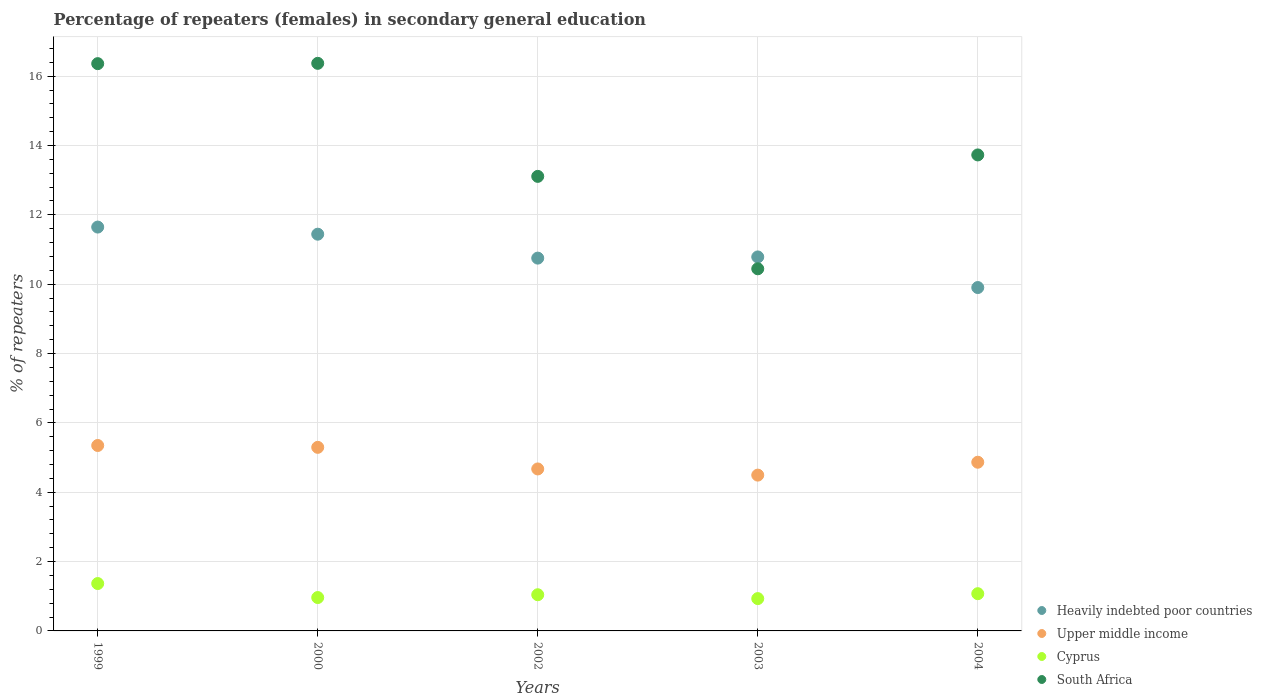What is the percentage of female repeaters in Heavily indebted poor countries in 1999?
Your answer should be compact. 11.65. Across all years, what is the maximum percentage of female repeaters in South Africa?
Your response must be concise. 16.37. Across all years, what is the minimum percentage of female repeaters in South Africa?
Your answer should be compact. 10.44. In which year was the percentage of female repeaters in South Africa maximum?
Keep it short and to the point. 2000. What is the total percentage of female repeaters in Cyprus in the graph?
Give a very brief answer. 5.38. What is the difference between the percentage of female repeaters in Heavily indebted poor countries in 1999 and that in 2004?
Offer a very short reply. 1.74. What is the difference between the percentage of female repeaters in Upper middle income in 2004 and the percentage of female repeaters in Cyprus in 2002?
Provide a succinct answer. 3.82. What is the average percentage of female repeaters in Heavily indebted poor countries per year?
Your answer should be very brief. 10.91. In the year 2004, what is the difference between the percentage of female repeaters in Cyprus and percentage of female repeaters in Heavily indebted poor countries?
Provide a succinct answer. -8.83. In how many years, is the percentage of female repeaters in Heavily indebted poor countries greater than 12.4 %?
Your answer should be compact. 0. What is the ratio of the percentage of female repeaters in South Africa in 1999 to that in 2004?
Provide a short and direct response. 1.19. Is the difference between the percentage of female repeaters in Cyprus in 1999 and 2002 greater than the difference between the percentage of female repeaters in Heavily indebted poor countries in 1999 and 2002?
Offer a very short reply. No. What is the difference between the highest and the second highest percentage of female repeaters in Cyprus?
Ensure brevity in your answer.  0.29. What is the difference between the highest and the lowest percentage of female repeaters in Cyprus?
Provide a short and direct response. 0.43. Is it the case that in every year, the sum of the percentage of female repeaters in Upper middle income and percentage of female repeaters in Heavily indebted poor countries  is greater than the sum of percentage of female repeaters in Cyprus and percentage of female repeaters in South Africa?
Your answer should be very brief. No. Is the percentage of female repeaters in Cyprus strictly greater than the percentage of female repeaters in Heavily indebted poor countries over the years?
Offer a very short reply. No. How many dotlines are there?
Keep it short and to the point. 4. Does the graph contain grids?
Offer a terse response. Yes. How many legend labels are there?
Your response must be concise. 4. What is the title of the graph?
Your response must be concise. Percentage of repeaters (females) in secondary general education. What is the label or title of the Y-axis?
Keep it short and to the point. % of repeaters. What is the % of repeaters in Heavily indebted poor countries in 1999?
Your answer should be compact. 11.65. What is the % of repeaters in Upper middle income in 1999?
Provide a succinct answer. 5.35. What is the % of repeaters in Cyprus in 1999?
Keep it short and to the point. 1.37. What is the % of repeaters of South Africa in 1999?
Offer a terse response. 16.36. What is the % of repeaters of Heavily indebted poor countries in 2000?
Keep it short and to the point. 11.44. What is the % of repeaters in Upper middle income in 2000?
Your answer should be compact. 5.29. What is the % of repeaters in Cyprus in 2000?
Provide a succinct answer. 0.96. What is the % of repeaters in South Africa in 2000?
Make the answer very short. 16.37. What is the % of repeaters in Heavily indebted poor countries in 2002?
Offer a terse response. 10.75. What is the % of repeaters in Upper middle income in 2002?
Your response must be concise. 4.67. What is the % of repeaters of Cyprus in 2002?
Offer a terse response. 1.04. What is the % of repeaters of South Africa in 2002?
Keep it short and to the point. 13.11. What is the % of repeaters in Heavily indebted poor countries in 2003?
Give a very brief answer. 10.79. What is the % of repeaters in Upper middle income in 2003?
Offer a very short reply. 4.49. What is the % of repeaters in Cyprus in 2003?
Your answer should be compact. 0.93. What is the % of repeaters of South Africa in 2003?
Offer a very short reply. 10.44. What is the % of repeaters of Heavily indebted poor countries in 2004?
Offer a terse response. 9.9. What is the % of repeaters of Upper middle income in 2004?
Make the answer very short. 4.86. What is the % of repeaters of Cyprus in 2004?
Offer a very short reply. 1.07. What is the % of repeaters of South Africa in 2004?
Provide a short and direct response. 13.73. Across all years, what is the maximum % of repeaters in Heavily indebted poor countries?
Your answer should be very brief. 11.65. Across all years, what is the maximum % of repeaters in Upper middle income?
Provide a short and direct response. 5.35. Across all years, what is the maximum % of repeaters in Cyprus?
Ensure brevity in your answer.  1.37. Across all years, what is the maximum % of repeaters in South Africa?
Offer a terse response. 16.37. Across all years, what is the minimum % of repeaters in Heavily indebted poor countries?
Make the answer very short. 9.9. Across all years, what is the minimum % of repeaters in Upper middle income?
Provide a short and direct response. 4.49. Across all years, what is the minimum % of repeaters in Cyprus?
Provide a short and direct response. 0.93. Across all years, what is the minimum % of repeaters of South Africa?
Your response must be concise. 10.44. What is the total % of repeaters in Heavily indebted poor countries in the graph?
Your answer should be very brief. 54.53. What is the total % of repeaters in Upper middle income in the graph?
Offer a terse response. 24.67. What is the total % of repeaters in Cyprus in the graph?
Provide a succinct answer. 5.38. What is the total % of repeaters in South Africa in the graph?
Give a very brief answer. 70.01. What is the difference between the % of repeaters in Heavily indebted poor countries in 1999 and that in 2000?
Ensure brevity in your answer.  0.21. What is the difference between the % of repeaters in Upper middle income in 1999 and that in 2000?
Give a very brief answer. 0.05. What is the difference between the % of repeaters of Cyprus in 1999 and that in 2000?
Your answer should be compact. 0.4. What is the difference between the % of repeaters of South Africa in 1999 and that in 2000?
Your response must be concise. -0.01. What is the difference between the % of repeaters of Heavily indebted poor countries in 1999 and that in 2002?
Make the answer very short. 0.9. What is the difference between the % of repeaters of Upper middle income in 1999 and that in 2002?
Offer a very short reply. 0.68. What is the difference between the % of repeaters in Cyprus in 1999 and that in 2002?
Keep it short and to the point. 0.32. What is the difference between the % of repeaters in South Africa in 1999 and that in 2002?
Offer a very short reply. 3.25. What is the difference between the % of repeaters of Heavily indebted poor countries in 1999 and that in 2003?
Your response must be concise. 0.86. What is the difference between the % of repeaters of Upper middle income in 1999 and that in 2003?
Your answer should be compact. 0.85. What is the difference between the % of repeaters of Cyprus in 1999 and that in 2003?
Keep it short and to the point. 0.43. What is the difference between the % of repeaters of South Africa in 1999 and that in 2003?
Make the answer very short. 5.92. What is the difference between the % of repeaters in Heavily indebted poor countries in 1999 and that in 2004?
Your answer should be very brief. 1.74. What is the difference between the % of repeaters in Upper middle income in 1999 and that in 2004?
Provide a succinct answer. 0.48. What is the difference between the % of repeaters in Cyprus in 1999 and that in 2004?
Keep it short and to the point. 0.29. What is the difference between the % of repeaters of South Africa in 1999 and that in 2004?
Your answer should be very brief. 2.63. What is the difference between the % of repeaters in Heavily indebted poor countries in 2000 and that in 2002?
Offer a very short reply. 0.69. What is the difference between the % of repeaters in Upper middle income in 2000 and that in 2002?
Keep it short and to the point. 0.62. What is the difference between the % of repeaters in Cyprus in 2000 and that in 2002?
Ensure brevity in your answer.  -0.08. What is the difference between the % of repeaters in South Africa in 2000 and that in 2002?
Your answer should be very brief. 3.26. What is the difference between the % of repeaters in Heavily indebted poor countries in 2000 and that in 2003?
Provide a succinct answer. 0.66. What is the difference between the % of repeaters in Upper middle income in 2000 and that in 2003?
Provide a succinct answer. 0.8. What is the difference between the % of repeaters in Cyprus in 2000 and that in 2003?
Your answer should be very brief. 0.03. What is the difference between the % of repeaters in South Africa in 2000 and that in 2003?
Offer a very short reply. 5.93. What is the difference between the % of repeaters of Heavily indebted poor countries in 2000 and that in 2004?
Your answer should be compact. 1.54. What is the difference between the % of repeaters of Upper middle income in 2000 and that in 2004?
Your answer should be compact. 0.43. What is the difference between the % of repeaters of Cyprus in 2000 and that in 2004?
Your answer should be compact. -0.11. What is the difference between the % of repeaters of South Africa in 2000 and that in 2004?
Offer a very short reply. 2.64. What is the difference between the % of repeaters of Heavily indebted poor countries in 2002 and that in 2003?
Keep it short and to the point. -0.03. What is the difference between the % of repeaters of Upper middle income in 2002 and that in 2003?
Keep it short and to the point. 0.18. What is the difference between the % of repeaters in Cyprus in 2002 and that in 2003?
Your response must be concise. 0.11. What is the difference between the % of repeaters of South Africa in 2002 and that in 2003?
Offer a terse response. 2.67. What is the difference between the % of repeaters of Heavily indebted poor countries in 2002 and that in 2004?
Make the answer very short. 0.85. What is the difference between the % of repeaters of Upper middle income in 2002 and that in 2004?
Provide a short and direct response. -0.19. What is the difference between the % of repeaters in Cyprus in 2002 and that in 2004?
Your response must be concise. -0.03. What is the difference between the % of repeaters in South Africa in 2002 and that in 2004?
Make the answer very short. -0.62. What is the difference between the % of repeaters of Heavily indebted poor countries in 2003 and that in 2004?
Provide a short and direct response. 0.88. What is the difference between the % of repeaters in Upper middle income in 2003 and that in 2004?
Your answer should be compact. -0.37. What is the difference between the % of repeaters of Cyprus in 2003 and that in 2004?
Give a very brief answer. -0.14. What is the difference between the % of repeaters of South Africa in 2003 and that in 2004?
Ensure brevity in your answer.  -3.28. What is the difference between the % of repeaters of Heavily indebted poor countries in 1999 and the % of repeaters of Upper middle income in 2000?
Keep it short and to the point. 6.35. What is the difference between the % of repeaters in Heavily indebted poor countries in 1999 and the % of repeaters in Cyprus in 2000?
Offer a terse response. 10.68. What is the difference between the % of repeaters of Heavily indebted poor countries in 1999 and the % of repeaters of South Africa in 2000?
Provide a succinct answer. -4.72. What is the difference between the % of repeaters in Upper middle income in 1999 and the % of repeaters in Cyprus in 2000?
Ensure brevity in your answer.  4.39. What is the difference between the % of repeaters in Upper middle income in 1999 and the % of repeaters in South Africa in 2000?
Offer a very short reply. -11.02. What is the difference between the % of repeaters of Cyprus in 1999 and the % of repeaters of South Africa in 2000?
Provide a succinct answer. -15. What is the difference between the % of repeaters of Heavily indebted poor countries in 1999 and the % of repeaters of Upper middle income in 2002?
Your answer should be compact. 6.98. What is the difference between the % of repeaters of Heavily indebted poor countries in 1999 and the % of repeaters of Cyprus in 2002?
Provide a short and direct response. 10.6. What is the difference between the % of repeaters in Heavily indebted poor countries in 1999 and the % of repeaters in South Africa in 2002?
Offer a terse response. -1.46. What is the difference between the % of repeaters in Upper middle income in 1999 and the % of repeaters in Cyprus in 2002?
Offer a very short reply. 4.3. What is the difference between the % of repeaters of Upper middle income in 1999 and the % of repeaters of South Africa in 2002?
Provide a short and direct response. -7.76. What is the difference between the % of repeaters of Cyprus in 1999 and the % of repeaters of South Africa in 2002?
Your answer should be very brief. -11.74. What is the difference between the % of repeaters in Heavily indebted poor countries in 1999 and the % of repeaters in Upper middle income in 2003?
Ensure brevity in your answer.  7.15. What is the difference between the % of repeaters of Heavily indebted poor countries in 1999 and the % of repeaters of Cyprus in 2003?
Your answer should be compact. 10.71. What is the difference between the % of repeaters of Heavily indebted poor countries in 1999 and the % of repeaters of South Africa in 2003?
Offer a terse response. 1.2. What is the difference between the % of repeaters in Upper middle income in 1999 and the % of repeaters in Cyprus in 2003?
Offer a terse response. 4.42. What is the difference between the % of repeaters in Upper middle income in 1999 and the % of repeaters in South Africa in 2003?
Provide a succinct answer. -5.1. What is the difference between the % of repeaters of Cyprus in 1999 and the % of repeaters of South Africa in 2003?
Provide a short and direct response. -9.08. What is the difference between the % of repeaters in Heavily indebted poor countries in 1999 and the % of repeaters in Upper middle income in 2004?
Offer a very short reply. 6.78. What is the difference between the % of repeaters in Heavily indebted poor countries in 1999 and the % of repeaters in Cyprus in 2004?
Ensure brevity in your answer.  10.57. What is the difference between the % of repeaters of Heavily indebted poor countries in 1999 and the % of repeaters of South Africa in 2004?
Your answer should be very brief. -2.08. What is the difference between the % of repeaters in Upper middle income in 1999 and the % of repeaters in Cyprus in 2004?
Make the answer very short. 4.27. What is the difference between the % of repeaters in Upper middle income in 1999 and the % of repeaters in South Africa in 2004?
Offer a terse response. -8.38. What is the difference between the % of repeaters in Cyprus in 1999 and the % of repeaters in South Africa in 2004?
Your response must be concise. -12.36. What is the difference between the % of repeaters in Heavily indebted poor countries in 2000 and the % of repeaters in Upper middle income in 2002?
Provide a short and direct response. 6.77. What is the difference between the % of repeaters in Heavily indebted poor countries in 2000 and the % of repeaters in Cyprus in 2002?
Your answer should be very brief. 10.4. What is the difference between the % of repeaters of Heavily indebted poor countries in 2000 and the % of repeaters of South Africa in 2002?
Offer a terse response. -1.67. What is the difference between the % of repeaters of Upper middle income in 2000 and the % of repeaters of Cyprus in 2002?
Make the answer very short. 4.25. What is the difference between the % of repeaters of Upper middle income in 2000 and the % of repeaters of South Africa in 2002?
Your response must be concise. -7.81. What is the difference between the % of repeaters of Cyprus in 2000 and the % of repeaters of South Africa in 2002?
Provide a succinct answer. -12.15. What is the difference between the % of repeaters of Heavily indebted poor countries in 2000 and the % of repeaters of Upper middle income in 2003?
Keep it short and to the point. 6.95. What is the difference between the % of repeaters in Heavily indebted poor countries in 2000 and the % of repeaters in Cyprus in 2003?
Offer a terse response. 10.51. What is the difference between the % of repeaters of Upper middle income in 2000 and the % of repeaters of Cyprus in 2003?
Offer a very short reply. 4.36. What is the difference between the % of repeaters in Upper middle income in 2000 and the % of repeaters in South Africa in 2003?
Give a very brief answer. -5.15. What is the difference between the % of repeaters in Cyprus in 2000 and the % of repeaters in South Africa in 2003?
Keep it short and to the point. -9.48. What is the difference between the % of repeaters of Heavily indebted poor countries in 2000 and the % of repeaters of Upper middle income in 2004?
Your answer should be compact. 6.58. What is the difference between the % of repeaters of Heavily indebted poor countries in 2000 and the % of repeaters of Cyprus in 2004?
Provide a succinct answer. 10.37. What is the difference between the % of repeaters of Heavily indebted poor countries in 2000 and the % of repeaters of South Africa in 2004?
Ensure brevity in your answer.  -2.29. What is the difference between the % of repeaters of Upper middle income in 2000 and the % of repeaters of Cyprus in 2004?
Your answer should be very brief. 4.22. What is the difference between the % of repeaters of Upper middle income in 2000 and the % of repeaters of South Africa in 2004?
Your response must be concise. -8.43. What is the difference between the % of repeaters in Cyprus in 2000 and the % of repeaters in South Africa in 2004?
Make the answer very short. -12.76. What is the difference between the % of repeaters of Heavily indebted poor countries in 2002 and the % of repeaters of Upper middle income in 2003?
Offer a terse response. 6.26. What is the difference between the % of repeaters in Heavily indebted poor countries in 2002 and the % of repeaters in Cyprus in 2003?
Make the answer very short. 9.82. What is the difference between the % of repeaters of Heavily indebted poor countries in 2002 and the % of repeaters of South Africa in 2003?
Your answer should be very brief. 0.31. What is the difference between the % of repeaters in Upper middle income in 2002 and the % of repeaters in Cyprus in 2003?
Offer a terse response. 3.74. What is the difference between the % of repeaters of Upper middle income in 2002 and the % of repeaters of South Africa in 2003?
Offer a very short reply. -5.77. What is the difference between the % of repeaters in Cyprus in 2002 and the % of repeaters in South Africa in 2003?
Provide a succinct answer. -9.4. What is the difference between the % of repeaters in Heavily indebted poor countries in 2002 and the % of repeaters in Upper middle income in 2004?
Your answer should be very brief. 5.89. What is the difference between the % of repeaters in Heavily indebted poor countries in 2002 and the % of repeaters in Cyprus in 2004?
Your answer should be very brief. 9.68. What is the difference between the % of repeaters in Heavily indebted poor countries in 2002 and the % of repeaters in South Africa in 2004?
Offer a very short reply. -2.98. What is the difference between the % of repeaters in Upper middle income in 2002 and the % of repeaters in Cyprus in 2004?
Your answer should be very brief. 3.6. What is the difference between the % of repeaters in Upper middle income in 2002 and the % of repeaters in South Africa in 2004?
Offer a very short reply. -9.06. What is the difference between the % of repeaters in Cyprus in 2002 and the % of repeaters in South Africa in 2004?
Your answer should be very brief. -12.68. What is the difference between the % of repeaters of Heavily indebted poor countries in 2003 and the % of repeaters of Upper middle income in 2004?
Your answer should be compact. 5.92. What is the difference between the % of repeaters in Heavily indebted poor countries in 2003 and the % of repeaters in Cyprus in 2004?
Your response must be concise. 9.71. What is the difference between the % of repeaters in Heavily indebted poor countries in 2003 and the % of repeaters in South Africa in 2004?
Provide a succinct answer. -2.94. What is the difference between the % of repeaters of Upper middle income in 2003 and the % of repeaters of Cyprus in 2004?
Make the answer very short. 3.42. What is the difference between the % of repeaters in Upper middle income in 2003 and the % of repeaters in South Africa in 2004?
Your answer should be compact. -9.23. What is the difference between the % of repeaters of Cyprus in 2003 and the % of repeaters of South Africa in 2004?
Provide a succinct answer. -12.8. What is the average % of repeaters in Heavily indebted poor countries per year?
Your answer should be compact. 10.91. What is the average % of repeaters in Upper middle income per year?
Provide a succinct answer. 4.93. What is the average % of repeaters in Cyprus per year?
Your response must be concise. 1.08. What is the average % of repeaters of South Africa per year?
Your answer should be compact. 14. In the year 1999, what is the difference between the % of repeaters in Heavily indebted poor countries and % of repeaters in Upper middle income?
Provide a short and direct response. 6.3. In the year 1999, what is the difference between the % of repeaters of Heavily indebted poor countries and % of repeaters of Cyprus?
Keep it short and to the point. 10.28. In the year 1999, what is the difference between the % of repeaters of Heavily indebted poor countries and % of repeaters of South Africa?
Offer a terse response. -4.71. In the year 1999, what is the difference between the % of repeaters of Upper middle income and % of repeaters of Cyprus?
Give a very brief answer. 3.98. In the year 1999, what is the difference between the % of repeaters of Upper middle income and % of repeaters of South Africa?
Make the answer very short. -11.01. In the year 1999, what is the difference between the % of repeaters in Cyprus and % of repeaters in South Africa?
Provide a short and direct response. -14.99. In the year 2000, what is the difference between the % of repeaters of Heavily indebted poor countries and % of repeaters of Upper middle income?
Your answer should be very brief. 6.15. In the year 2000, what is the difference between the % of repeaters of Heavily indebted poor countries and % of repeaters of Cyprus?
Provide a succinct answer. 10.48. In the year 2000, what is the difference between the % of repeaters in Heavily indebted poor countries and % of repeaters in South Africa?
Provide a short and direct response. -4.93. In the year 2000, what is the difference between the % of repeaters of Upper middle income and % of repeaters of Cyprus?
Your response must be concise. 4.33. In the year 2000, what is the difference between the % of repeaters of Upper middle income and % of repeaters of South Africa?
Make the answer very short. -11.07. In the year 2000, what is the difference between the % of repeaters in Cyprus and % of repeaters in South Africa?
Provide a succinct answer. -15.41. In the year 2002, what is the difference between the % of repeaters of Heavily indebted poor countries and % of repeaters of Upper middle income?
Your answer should be compact. 6.08. In the year 2002, what is the difference between the % of repeaters in Heavily indebted poor countries and % of repeaters in Cyprus?
Offer a terse response. 9.71. In the year 2002, what is the difference between the % of repeaters in Heavily indebted poor countries and % of repeaters in South Africa?
Your answer should be compact. -2.36. In the year 2002, what is the difference between the % of repeaters of Upper middle income and % of repeaters of Cyprus?
Your answer should be compact. 3.63. In the year 2002, what is the difference between the % of repeaters in Upper middle income and % of repeaters in South Africa?
Your answer should be very brief. -8.44. In the year 2002, what is the difference between the % of repeaters of Cyprus and % of repeaters of South Africa?
Your answer should be very brief. -12.07. In the year 2003, what is the difference between the % of repeaters of Heavily indebted poor countries and % of repeaters of Upper middle income?
Keep it short and to the point. 6.29. In the year 2003, what is the difference between the % of repeaters of Heavily indebted poor countries and % of repeaters of Cyprus?
Provide a succinct answer. 9.85. In the year 2003, what is the difference between the % of repeaters of Heavily indebted poor countries and % of repeaters of South Africa?
Provide a succinct answer. 0.34. In the year 2003, what is the difference between the % of repeaters of Upper middle income and % of repeaters of Cyprus?
Your response must be concise. 3.56. In the year 2003, what is the difference between the % of repeaters of Upper middle income and % of repeaters of South Africa?
Provide a succinct answer. -5.95. In the year 2003, what is the difference between the % of repeaters of Cyprus and % of repeaters of South Africa?
Ensure brevity in your answer.  -9.51. In the year 2004, what is the difference between the % of repeaters in Heavily indebted poor countries and % of repeaters in Upper middle income?
Your response must be concise. 5.04. In the year 2004, what is the difference between the % of repeaters in Heavily indebted poor countries and % of repeaters in Cyprus?
Your response must be concise. 8.83. In the year 2004, what is the difference between the % of repeaters of Heavily indebted poor countries and % of repeaters of South Africa?
Offer a very short reply. -3.82. In the year 2004, what is the difference between the % of repeaters of Upper middle income and % of repeaters of Cyprus?
Give a very brief answer. 3.79. In the year 2004, what is the difference between the % of repeaters of Upper middle income and % of repeaters of South Africa?
Offer a very short reply. -8.86. In the year 2004, what is the difference between the % of repeaters of Cyprus and % of repeaters of South Africa?
Provide a short and direct response. -12.65. What is the ratio of the % of repeaters of Heavily indebted poor countries in 1999 to that in 2000?
Keep it short and to the point. 1.02. What is the ratio of the % of repeaters in Upper middle income in 1999 to that in 2000?
Your answer should be compact. 1.01. What is the ratio of the % of repeaters of Cyprus in 1999 to that in 2000?
Offer a very short reply. 1.42. What is the ratio of the % of repeaters of South Africa in 1999 to that in 2000?
Give a very brief answer. 1. What is the ratio of the % of repeaters of Heavily indebted poor countries in 1999 to that in 2002?
Offer a very short reply. 1.08. What is the ratio of the % of repeaters of Upper middle income in 1999 to that in 2002?
Make the answer very short. 1.14. What is the ratio of the % of repeaters in Cyprus in 1999 to that in 2002?
Give a very brief answer. 1.31. What is the ratio of the % of repeaters in South Africa in 1999 to that in 2002?
Keep it short and to the point. 1.25. What is the ratio of the % of repeaters in Heavily indebted poor countries in 1999 to that in 2003?
Your response must be concise. 1.08. What is the ratio of the % of repeaters of Upper middle income in 1999 to that in 2003?
Your answer should be very brief. 1.19. What is the ratio of the % of repeaters in Cyprus in 1999 to that in 2003?
Provide a short and direct response. 1.47. What is the ratio of the % of repeaters of South Africa in 1999 to that in 2003?
Your answer should be very brief. 1.57. What is the ratio of the % of repeaters in Heavily indebted poor countries in 1999 to that in 2004?
Offer a very short reply. 1.18. What is the ratio of the % of repeaters in Upper middle income in 1999 to that in 2004?
Provide a short and direct response. 1.1. What is the ratio of the % of repeaters of Cyprus in 1999 to that in 2004?
Give a very brief answer. 1.27. What is the ratio of the % of repeaters in South Africa in 1999 to that in 2004?
Provide a succinct answer. 1.19. What is the ratio of the % of repeaters of Heavily indebted poor countries in 2000 to that in 2002?
Keep it short and to the point. 1.06. What is the ratio of the % of repeaters of Upper middle income in 2000 to that in 2002?
Make the answer very short. 1.13. What is the ratio of the % of repeaters in Cyprus in 2000 to that in 2002?
Give a very brief answer. 0.92. What is the ratio of the % of repeaters in South Africa in 2000 to that in 2002?
Offer a very short reply. 1.25. What is the ratio of the % of repeaters of Heavily indebted poor countries in 2000 to that in 2003?
Your answer should be compact. 1.06. What is the ratio of the % of repeaters in Upper middle income in 2000 to that in 2003?
Offer a very short reply. 1.18. What is the ratio of the % of repeaters in Cyprus in 2000 to that in 2003?
Provide a short and direct response. 1.03. What is the ratio of the % of repeaters of South Africa in 2000 to that in 2003?
Make the answer very short. 1.57. What is the ratio of the % of repeaters in Heavily indebted poor countries in 2000 to that in 2004?
Provide a succinct answer. 1.16. What is the ratio of the % of repeaters of Upper middle income in 2000 to that in 2004?
Offer a very short reply. 1.09. What is the ratio of the % of repeaters in Cyprus in 2000 to that in 2004?
Offer a terse response. 0.9. What is the ratio of the % of repeaters of South Africa in 2000 to that in 2004?
Your answer should be very brief. 1.19. What is the ratio of the % of repeaters in Heavily indebted poor countries in 2002 to that in 2003?
Provide a short and direct response. 1. What is the ratio of the % of repeaters in Upper middle income in 2002 to that in 2003?
Ensure brevity in your answer.  1.04. What is the ratio of the % of repeaters in Cyprus in 2002 to that in 2003?
Make the answer very short. 1.12. What is the ratio of the % of repeaters in South Africa in 2002 to that in 2003?
Your response must be concise. 1.26. What is the ratio of the % of repeaters in Heavily indebted poor countries in 2002 to that in 2004?
Keep it short and to the point. 1.09. What is the ratio of the % of repeaters in Upper middle income in 2002 to that in 2004?
Ensure brevity in your answer.  0.96. What is the ratio of the % of repeaters of Cyprus in 2002 to that in 2004?
Ensure brevity in your answer.  0.97. What is the ratio of the % of repeaters of South Africa in 2002 to that in 2004?
Offer a terse response. 0.95. What is the ratio of the % of repeaters of Heavily indebted poor countries in 2003 to that in 2004?
Your answer should be compact. 1.09. What is the ratio of the % of repeaters in Upper middle income in 2003 to that in 2004?
Provide a short and direct response. 0.92. What is the ratio of the % of repeaters in Cyprus in 2003 to that in 2004?
Make the answer very short. 0.87. What is the ratio of the % of repeaters of South Africa in 2003 to that in 2004?
Your answer should be very brief. 0.76. What is the difference between the highest and the second highest % of repeaters in Heavily indebted poor countries?
Provide a short and direct response. 0.21. What is the difference between the highest and the second highest % of repeaters of Upper middle income?
Make the answer very short. 0.05. What is the difference between the highest and the second highest % of repeaters of Cyprus?
Ensure brevity in your answer.  0.29. What is the difference between the highest and the second highest % of repeaters of South Africa?
Provide a short and direct response. 0.01. What is the difference between the highest and the lowest % of repeaters of Heavily indebted poor countries?
Your answer should be very brief. 1.74. What is the difference between the highest and the lowest % of repeaters in Upper middle income?
Keep it short and to the point. 0.85. What is the difference between the highest and the lowest % of repeaters in Cyprus?
Ensure brevity in your answer.  0.43. What is the difference between the highest and the lowest % of repeaters in South Africa?
Your answer should be very brief. 5.93. 